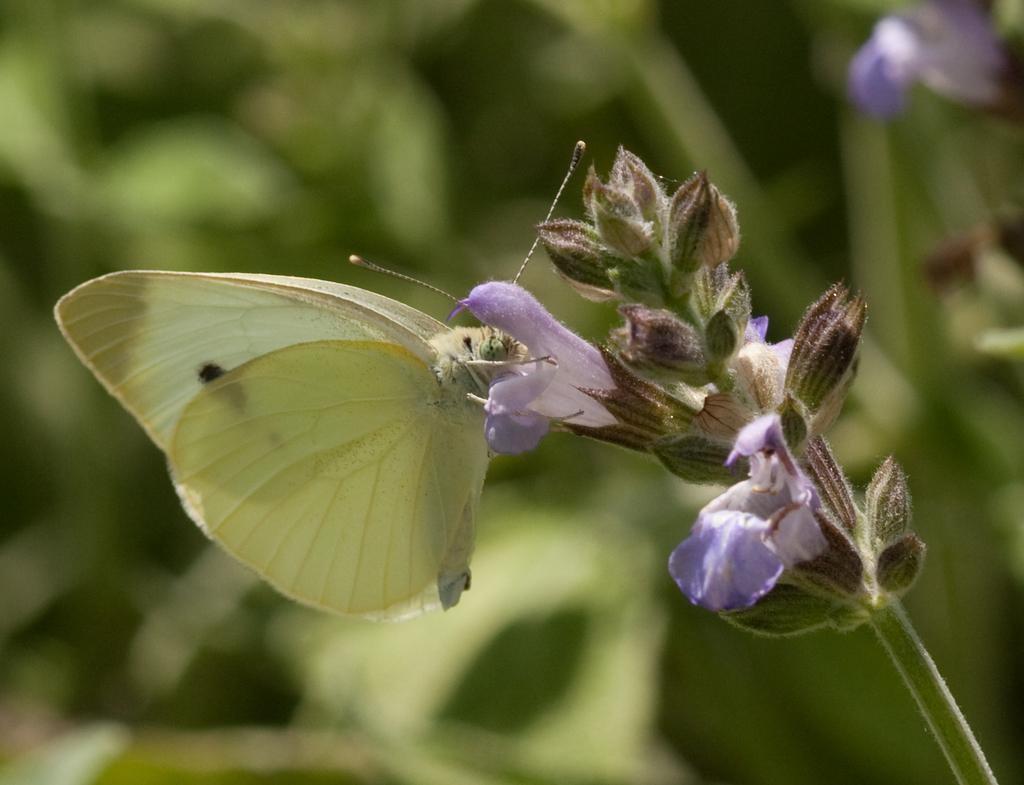Describe this image in one or two sentences. In this image we can see a butterfly on a flower which is to the stem of a plant. 